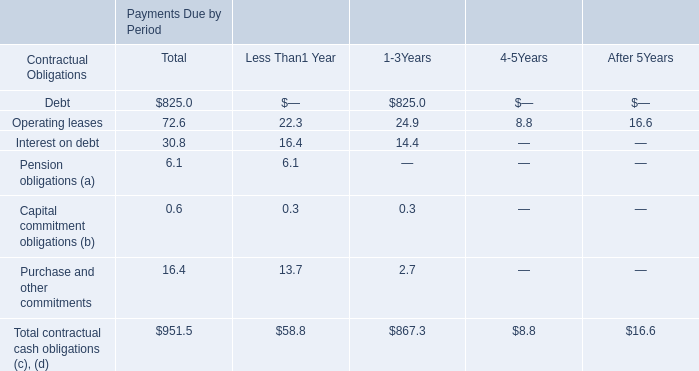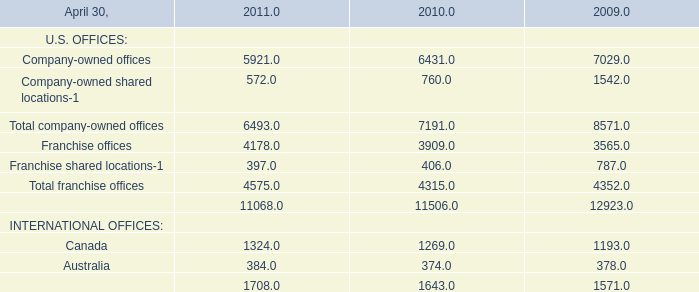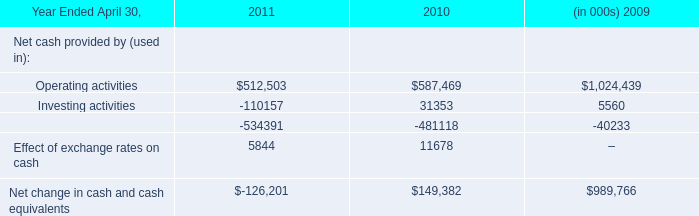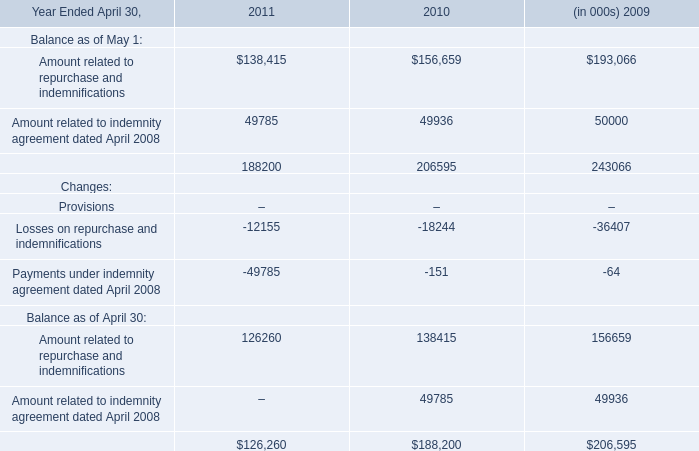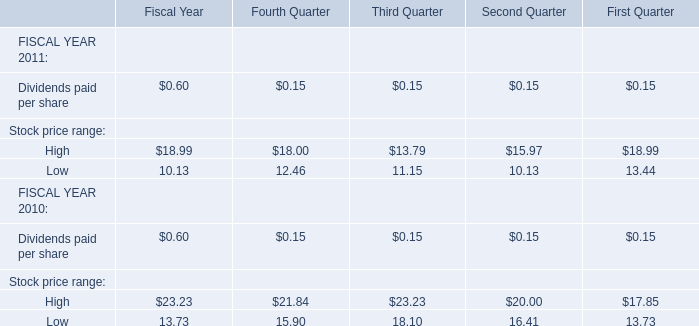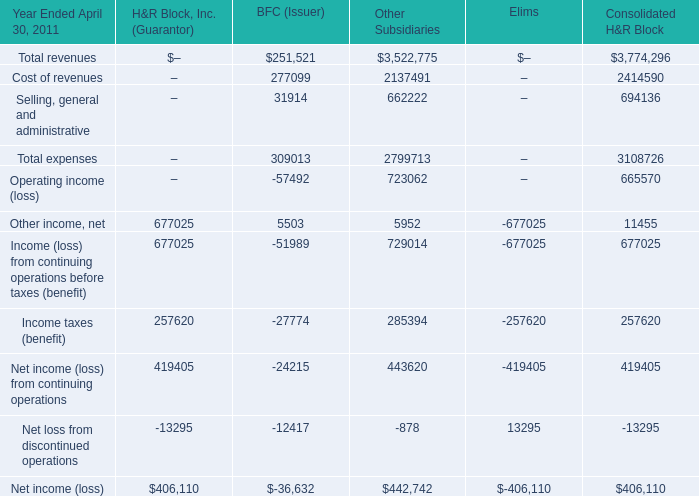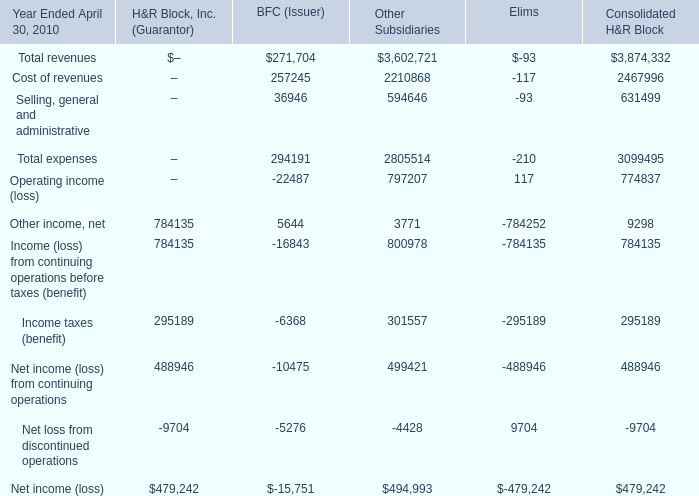What is the sum of Total revenues, Cost of revenues and Selling, general and administrative for BFC(Issuer) ? 
Computations: ((251521 + 277099) + 31914)
Answer: 560534.0. 